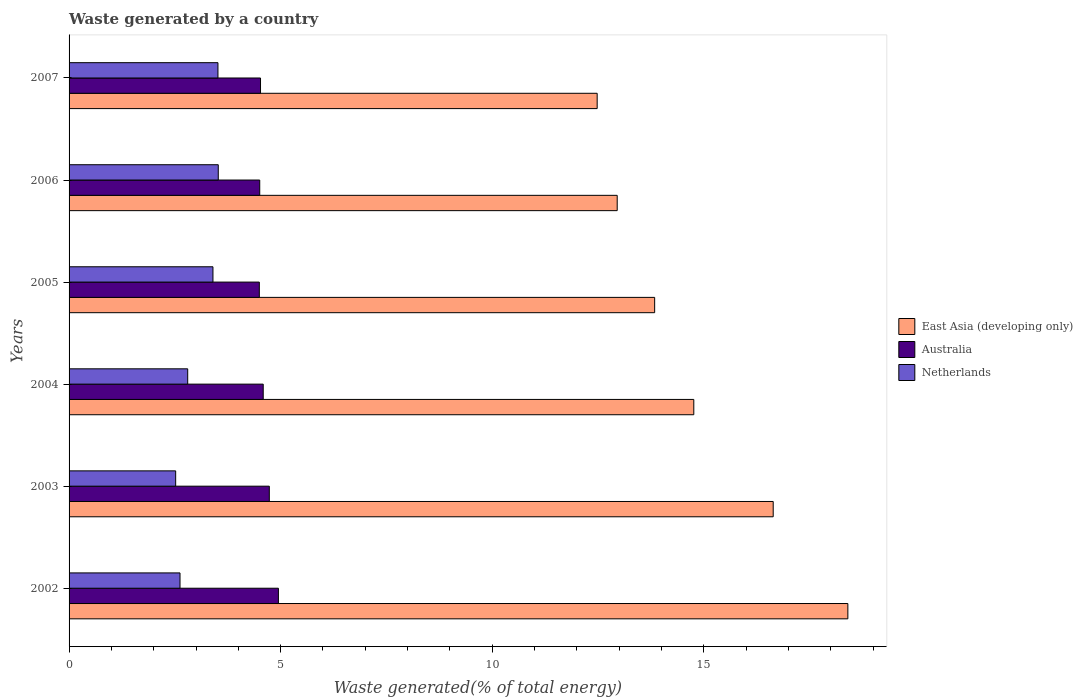How many groups of bars are there?
Your answer should be very brief. 6. Are the number of bars per tick equal to the number of legend labels?
Give a very brief answer. Yes. Are the number of bars on each tick of the Y-axis equal?
Your response must be concise. Yes. How many bars are there on the 5th tick from the top?
Your answer should be very brief. 3. What is the label of the 3rd group of bars from the top?
Provide a succinct answer. 2005. In how many cases, is the number of bars for a given year not equal to the number of legend labels?
Offer a very short reply. 0. What is the total waste generated in East Asia (developing only) in 2004?
Your answer should be compact. 14.76. Across all years, what is the maximum total waste generated in Netherlands?
Your answer should be compact. 3.53. Across all years, what is the minimum total waste generated in East Asia (developing only)?
Give a very brief answer. 12.48. In which year was the total waste generated in Australia minimum?
Ensure brevity in your answer.  2005. What is the total total waste generated in East Asia (developing only) in the graph?
Offer a terse response. 89.07. What is the difference between the total waste generated in Netherlands in 2005 and that in 2006?
Ensure brevity in your answer.  -0.13. What is the difference between the total waste generated in Australia in 2006 and the total waste generated in East Asia (developing only) in 2003?
Provide a short and direct response. -12.13. What is the average total waste generated in Australia per year?
Make the answer very short. 4.63. In the year 2006, what is the difference between the total waste generated in Netherlands and total waste generated in Australia?
Provide a short and direct response. -0.98. What is the ratio of the total waste generated in Netherlands in 2005 to that in 2006?
Your answer should be compact. 0.96. Is the total waste generated in East Asia (developing only) in 2003 less than that in 2007?
Keep it short and to the point. No. Is the difference between the total waste generated in Netherlands in 2004 and 2005 greater than the difference between the total waste generated in Australia in 2004 and 2005?
Provide a short and direct response. No. What is the difference between the highest and the second highest total waste generated in Australia?
Your response must be concise. 0.21. What is the difference between the highest and the lowest total waste generated in East Asia (developing only)?
Keep it short and to the point. 5.92. What does the 2nd bar from the top in 2007 represents?
Your answer should be very brief. Australia. What does the 3rd bar from the bottom in 2005 represents?
Make the answer very short. Netherlands. How many bars are there?
Provide a succinct answer. 18. Are all the bars in the graph horizontal?
Your answer should be very brief. Yes. How many years are there in the graph?
Ensure brevity in your answer.  6. Are the values on the major ticks of X-axis written in scientific E-notation?
Offer a terse response. No. Does the graph contain any zero values?
Give a very brief answer. No. How many legend labels are there?
Give a very brief answer. 3. What is the title of the graph?
Offer a terse response. Waste generated by a country. What is the label or title of the X-axis?
Keep it short and to the point. Waste generated(% of total energy). What is the Waste generated(% of total energy) of East Asia (developing only) in 2002?
Keep it short and to the point. 18.4. What is the Waste generated(% of total energy) in Australia in 2002?
Your answer should be compact. 4.95. What is the Waste generated(% of total energy) of Netherlands in 2002?
Your answer should be very brief. 2.62. What is the Waste generated(% of total energy) of East Asia (developing only) in 2003?
Offer a terse response. 16.64. What is the Waste generated(% of total energy) of Australia in 2003?
Offer a terse response. 4.73. What is the Waste generated(% of total energy) in Netherlands in 2003?
Your response must be concise. 2.52. What is the Waste generated(% of total energy) of East Asia (developing only) in 2004?
Offer a very short reply. 14.76. What is the Waste generated(% of total energy) in Australia in 2004?
Make the answer very short. 4.59. What is the Waste generated(% of total energy) in Netherlands in 2004?
Your response must be concise. 2.8. What is the Waste generated(% of total energy) in East Asia (developing only) in 2005?
Offer a terse response. 13.84. What is the Waste generated(% of total energy) in Australia in 2005?
Offer a very short reply. 4.5. What is the Waste generated(% of total energy) of Netherlands in 2005?
Your answer should be compact. 3.4. What is the Waste generated(% of total energy) in East Asia (developing only) in 2006?
Keep it short and to the point. 12.95. What is the Waste generated(% of total energy) in Australia in 2006?
Your answer should be very brief. 4.51. What is the Waste generated(% of total energy) in Netherlands in 2006?
Offer a terse response. 3.53. What is the Waste generated(% of total energy) in East Asia (developing only) in 2007?
Provide a succinct answer. 12.48. What is the Waste generated(% of total energy) in Australia in 2007?
Offer a very short reply. 4.52. What is the Waste generated(% of total energy) in Netherlands in 2007?
Make the answer very short. 3.52. Across all years, what is the maximum Waste generated(% of total energy) of East Asia (developing only)?
Provide a succinct answer. 18.4. Across all years, what is the maximum Waste generated(% of total energy) of Australia?
Keep it short and to the point. 4.95. Across all years, what is the maximum Waste generated(% of total energy) of Netherlands?
Your answer should be very brief. 3.53. Across all years, what is the minimum Waste generated(% of total energy) in East Asia (developing only)?
Keep it short and to the point. 12.48. Across all years, what is the minimum Waste generated(% of total energy) in Australia?
Keep it short and to the point. 4.5. Across all years, what is the minimum Waste generated(% of total energy) in Netherlands?
Provide a short and direct response. 2.52. What is the total Waste generated(% of total energy) of East Asia (developing only) in the graph?
Provide a succinct answer. 89.07. What is the total Waste generated(% of total energy) in Australia in the graph?
Offer a very short reply. 27.79. What is the total Waste generated(% of total energy) of Netherlands in the graph?
Your answer should be very brief. 18.39. What is the difference between the Waste generated(% of total energy) in East Asia (developing only) in 2002 and that in 2003?
Ensure brevity in your answer.  1.76. What is the difference between the Waste generated(% of total energy) of Australia in 2002 and that in 2003?
Offer a very short reply. 0.21. What is the difference between the Waste generated(% of total energy) in Netherlands in 2002 and that in 2003?
Provide a short and direct response. 0.1. What is the difference between the Waste generated(% of total energy) of East Asia (developing only) in 2002 and that in 2004?
Provide a short and direct response. 3.64. What is the difference between the Waste generated(% of total energy) of Australia in 2002 and that in 2004?
Your answer should be compact. 0.36. What is the difference between the Waste generated(% of total energy) of Netherlands in 2002 and that in 2004?
Your answer should be compact. -0.18. What is the difference between the Waste generated(% of total energy) in East Asia (developing only) in 2002 and that in 2005?
Make the answer very short. 4.57. What is the difference between the Waste generated(% of total energy) of Australia in 2002 and that in 2005?
Provide a short and direct response. 0.45. What is the difference between the Waste generated(% of total energy) in Netherlands in 2002 and that in 2005?
Provide a short and direct response. -0.78. What is the difference between the Waste generated(% of total energy) of East Asia (developing only) in 2002 and that in 2006?
Provide a short and direct response. 5.45. What is the difference between the Waste generated(% of total energy) of Australia in 2002 and that in 2006?
Your answer should be compact. 0.44. What is the difference between the Waste generated(% of total energy) of Netherlands in 2002 and that in 2006?
Offer a terse response. -0.9. What is the difference between the Waste generated(% of total energy) in East Asia (developing only) in 2002 and that in 2007?
Your answer should be very brief. 5.92. What is the difference between the Waste generated(% of total energy) in Australia in 2002 and that in 2007?
Keep it short and to the point. 0.42. What is the difference between the Waste generated(% of total energy) of Netherlands in 2002 and that in 2007?
Offer a terse response. -0.9. What is the difference between the Waste generated(% of total energy) of East Asia (developing only) in 2003 and that in 2004?
Provide a short and direct response. 1.88. What is the difference between the Waste generated(% of total energy) of Australia in 2003 and that in 2004?
Offer a terse response. 0.14. What is the difference between the Waste generated(% of total energy) of Netherlands in 2003 and that in 2004?
Give a very brief answer. -0.28. What is the difference between the Waste generated(% of total energy) in East Asia (developing only) in 2003 and that in 2005?
Provide a succinct answer. 2.8. What is the difference between the Waste generated(% of total energy) of Australia in 2003 and that in 2005?
Give a very brief answer. 0.24. What is the difference between the Waste generated(% of total energy) of Netherlands in 2003 and that in 2005?
Provide a short and direct response. -0.88. What is the difference between the Waste generated(% of total energy) of East Asia (developing only) in 2003 and that in 2006?
Provide a short and direct response. 3.69. What is the difference between the Waste generated(% of total energy) of Australia in 2003 and that in 2006?
Offer a very short reply. 0.23. What is the difference between the Waste generated(% of total energy) of Netherlands in 2003 and that in 2006?
Provide a short and direct response. -1.01. What is the difference between the Waste generated(% of total energy) in East Asia (developing only) in 2003 and that in 2007?
Give a very brief answer. 4.16. What is the difference between the Waste generated(% of total energy) in Australia in 2003 and that in 2007?
Offer a terse response. 0.21. What is the difference between the Waste generated(% of total energy) of Netherlands in 2003 and that in 2007?
Give a very brief answer. -1. What is the difference between the Waste generated(% of total energy) of East Asia (developing only) in 2004 and that in 2005?
Your response must be concise. 0.93. What is the difference between the Waste generated(% of total energy) in Australia in 2004 and that in 2005?
Your answer should be very brief. 0.09. What is the difference between the Waste generated(% of total energy) of Netherlands in 2004 and that in 2005?
Provide a short and direct response. -0.6. What is the difference between the Waste generated(% of total energy) in East Asia (developing only) in 2004 and that in 2006?
Offer a very short reply. 1.81. What is the difference between the Waste generated(% of total energy) of Australia in 2004 and that in 2006?
Ensure brevity in your answer.  0.08. What is the difference between the Waste generated(% of total energy) in Netherlands in 2004 and that in 2006?
Make the answer very short. -0.72. What is the difference between the Waste generated(% of total energy) of East Asia (developing only) in 2004 and that in 2007?
Provide a succinct answer. 2.28. What is the difference between the Waste generated(% of total energy) in Australia in 2004 and that in 2007?
Give a very brief answer. 0.06. What is the difference between the Waste generated(% of total energy) of Netherlands in 2004 and that in 2007?
Offer a terse response. -0.71. What is the difference between the Waste generated(% of total energy) of East Asia (developing only) in 2005 and that in 2006?
Provide a succinct answer. 0.88. What is the difference between the Waste generated(% of total energy) of Australia in 2005 and that in 2006?
Offer a terse response. -0.01. What is the difference between the Waste generated(% of total energy) in Netherlands in 2005 and that in 2006?
Make the answer very short. -0.13. What is the difference between the Waste generated(% of total energy) in East Asia (developing only) in 2005 and that in 2007?
Ensure brevity in your answer.  1.36. What is the difference between the Waste generated(% of total energy) in Australia in 2005 and that in 2007?
Give a very brief answer. -0.03. What is the difference between the Waste generated(% of total energy) in Netherlands in 2005 and that in 2007?
Your answer should be compact. -0.12. What is the difference between the Waste generated(% of total energy) of East Asia (developing only) in 2006 and that in 2007?
Give a very brief answer. 0.47. What is the difference between the Waste generated(% of total energy) in Australia in 2006 and that in 2007?
Keep it short and to the point. -0.02. What is the difference between the Waste generated(% of total energy) in Netherlands in 2006 and that in 2007?
Offer a very short reply. 0.01. What is the difference between the Waste generated(% of total energy) in East Asia (developing only) in 2002 and the Waste generated(% of total energy) in Australia in 2003?
Provide a succinct answer. 13.67. What is the difference between the Waste generated(% of total energy) of East Asia (developing only) in 2002 and the Waste generated(% of total energy) of Netherlands in 2003?
Your answer should be very brief. 15.88. What is the difference between the Waste generated(% of total energy) in Australia in 2002 and the Waste generated(% of total energy) in Netherlands in 2003?
Provide a short and direct response. 2.43. What is the difference between the Waste generated(% of total energy) of East Asia (developing only) in 2002 and the Waste generated(% of total energy) of Australia in 2004?
Your answer should be very brief. 13.81. What is the difference between the Waste generated(% of total energy) in East Asia (developing only) in 2002 and the Waste generated(% of total energy) in Netherlands in 2004?
Offer a terse response. 15.6. What is the difference between the Waste generated(% of total energy) in Australia in 2002 and the Waste generated(% of total energy) in Netherlands in 2004?
Make the answer very short. 2.14. What is the difference between the Waste generated(% of total energy) of East Asia (developing only) in 2002 and the Waste generated(% of total energy) of Australia in 2005?
Make the answer very short. 13.91. What is the difference between the Waste generated(% of total energy) of East Asia (developing only) in 2002 and the Waste generated(% of total energy) of Netherlands in 2005?
Provide a short and direct response. 15. What is the difference between the Waste generated(% of total energy) in Australia in 2002 and the Waste generated(% of total energy) in Netherlands in 2005?
Offer a terse response. 1.55. What is the difference between the Waste generated(% of total energy) in East Asia (developing only) in 2002 and the Waste generated(% of total energy) in Australia in 2006?
Provide a succinct answer. 13.9. What is the difference between the Waste generated(% of total energy) of East Asia (developing only) in 2002 and the Waste generated(% of total energy) of Netherlands in 2006?
Your answer should be compact. 14.88. What is the difference between the Waste generated(% of total energy) in Australia in 2002 and the Waste generated(% of total energy) in Netherlands in 2006?
Provide a succinct answer. 1.42. What is the difference between the Waste generated(% of total energy) of East Asia (developing only) in 2002 and the Waste generated(% of total energy) of Australia in 2007?
Provide a succinct answer. 13.88. What is the difference between the Waste generated(% of total energy) in East Asia (developing only) in 2002 and the Waste generated(% of total energy) in Netherlands in 2007?
Offer a terse response. 14.88. What is the difference between the Waste generated(% of total energy) in Australia in 2002 and the Waste generated(% of total energy) in Netherlands in 2007?
Your answer should be very brief. 1.43. What is the difference between the Waste generated(% of total energy) of East Asia (developing only) in 2003 and the Waste generated(% of total energy) of Australia in 2004?
Give a very brief answer. 12.05. What is the difference between the Waste generated(% of total energy) in East Asia (developing only) in 2003 and the Waste generated(% of total energy) in Netherlands in 2004?
Offer a terse response. 13.84. What is the difference between the Waste generated(% of total energy) in Australia in 2003 and the Waste generated(% of total energy) in Netherlands in 2004?
Your response must be concise. 1.93. What is the difference between the Waste generated(% of total energy) of East Asia (developing only) in 2003 and the Waste generated(% of total energy) of Australia in 2005?
Keep it short and to the point. 12.14. What is the difference between the Waste generated(% of total energy) of East Asia (developing only) in 2003 and the Waste generated(% of total energy) of Netherlands in 2005?
Your response must be concise. 13.24. What is the difference between the Waste generated(% of total energy) of Australia in 2003 and the Waste generated(% of total energy) of Netherlands in 2005?
Give a very brief answer. 1.33. What is the difference between the Waste generated(% of total energy) of East Asia (developing only) in 2003 and the Waste generated(% of total energy) of Australia in 2006?
Make the answer very short. 12.13. What is the difference between the Waste generated(% of total energy) in East Asia (developing only) in 2003 and the Waste generated(% of total energy) in Netherlands in 2006?
Provide a succinct answer. 13.11. What is the difference between the Waste generated(% of total energy) in Australia in 2003 and the Waste generated(% of total energy) in Netherlands in 2006?
Offer a very short reply. 1.21. What is the difference between the Waste generated(% of total energy) of East Asia (developing only) in 2003 and the Waste generated(% of total energy) of Australia in 2007?
Provide a short and direct response. 12.11. What is the difference between the Waste generated(% of total energy) in East Asia (developing only) in 2003 and the Waste generated(% of total energy) in Netherlands in 2007?
Provide a short and direct response. 13.12. What is the difference between the Waste generated(% of total energy) in Australia in 2003 and the Waste generated(% of total energy) in Netherlands in 2007?
Your answer should be compact. 1.21. What is the difference between the Waste generated(% of total energy) of East Asia (developing only) in 2004 and the Waste generated(% of total energy) of Australia in 2005?
Your answer should be very brief. 10.27. What is the difference between the Waste generated(% of total energy) in East Asia (developing only) in 2004 and the Waste generated(% of total energy) in Netherlands in 2005?
Keep it short and to the point. 11.36. What is the difference between the Waste generated(% of total energy) in Australia in 2004 and the Waste generated(% of total energy) in Netherlands in 2005?
Provide a succinct answer. 1.19. What is the difference between the Waste generated(% of total energy) in East Asia (developing only) in 2004 and the Waste generated(% of total energy) in Australia in 2006?
Make the answer very short. 10.26. What is the difference between the Waste generated(% of total energy) in East Asia (developing only) in 2004 and the Waste generated(% of total energy) in Netherlands in 2006?
Offer a terse response. 11.24. What is the difference between the Waste generated(% of total energy) in Australia in 2004 and the Waste generated(% of total energy) in Netherlands in 2006?
Keep it short and to the point. 1.06. What is the difference between the Waste generated(% of total energy) in East Asia (developing only) in 2004 and the Waste generated(% of total energy) in Australia in 2007?
Your response must be concise. 10.24. What is the difference between the Waste generated(% of total energy) in East Asia (developing only) in 2004 and the Waste generated(% of total energy) in Netherlands in 2007?
Provide a short and direct response. 11.24. What is the difference between the Waste generated(% of total energy) in Australia in 2004 and the Waste generated(% of total energy) in Netherlands in 2007?
Offer a terse response. 1.07. What is the difference between the Waste generated(% of total energy) in East Asia (developing only) in 2005 and the Waste generated(% of total energy) in Australia in 2006?
Keep it short and to the point. 9.33. What is the difference between the Waste generated(% of total energy) in East Asia (developing only) in 2005 and the Waste generated(% of total energy) in Netherlands in 2006?
Offer a very short reply. 10.31. What is the difference between the Waste generated(% of total energy) of Australia in 2005 and the Waste generated(% of total energy) of Netherlands in 2006?
Offer a terse response. 0.97. What is the difference between the Waste generated(% of total energy) in East Asia (developing only) in 2005 and the Waste generated(% of total energy) in Australia in 2007?
Ensure brevity in your answer.  9.31. What is the difference between the Waste generated(% of total energy) of East Asia (developing only) in 2005 and the Waste generated(% of total energy) of Netherlands in 2007?
Your answer should be compact. 10.32. What is the difference between the Waste generated(% of total energy) in Australia in 2005 and the Waste generated(% of total energy) in Netherlands in 2007?
Give a very brief answer. 0.98. What is the difference between the Waste generated(% of total energy) of East Asia (developing only) in 2006 and the Waste generated(% of total energy) of Australia in 2007?
Your answer should be compact. 8.43. What is the difference between the Waste generated(% of total energy) of East Asia (developing only) in 2006 and the Waste generated(% of total energy) of Netherlands in 2007?
Make the answer very short. 9.43. What is the difference between the Waste generated(% of total energy) of Australia in 2006 and the Waste generated(% of total energy) of Netherlands in 2007?
Your answer should be compact. 0.99. What is the average Waste generated(% of total energy) in East Asia (developing only) per year?
Your answer should be very brief. 14.85. What is the average Waste generated(% of total energy) in Australia per year?
Provide a short and direct response. 4.63. What is the average Waste generated(% of total energy) in Netherlands per year?
Your answer should be very brief. 3.06. In the year 2002, what is the difference between the Waste generated(% of total energy) in East Asia (developing only) and Waste generated(% of total energy) in Australia?
Provide a succinct answer. 13.46. In the year 2002, what is the difference between the Waste generated(% of total energy) in East Asia (developing only) and Waste generated(% of total energy) in Netherlands?
Make the answer very short. 15.78. In the year 2002, what is the difference between the Waste generated(% of total energy) in Australia and Waste generated(% of total energy) in Netherlands?
Offer a very short reply. 2.32. In the year 2003, what is the difference between the Waste generated(% of total energy) of East Asia (developing only) and Waste generated(% of total energy) of Australia?
Provide a succinct answer. 11.91. In the year 2003, what is the difference between the Waste generated(% of total energy) in East Asia (developing only) and Waste generated(% of total energy) in Netherlands?
Keep it short and to the point. 14.12. In the year 2003, what is the difference between the Waste generated(% of total energy) of Australia and Waste generated(% of total energy) of Netherlands?
Keep it short and to the point. 2.21. In the year 2004, what is the difference between the Waste generated(% of total energy) in East Asia (developing only) and Waste generated(% of total energy) in Australia?
Your response must be concise. 10.17. In the year 2004, what is the difference between the Waste generated(% of total energy) in East Asia (developing only) and Waste generated(% of total energy) in Netherlands?
Provide a succinct answer. 11.96. In the year 2004, what is the difference between the Waste generated(% of total energy) in Australia and Waste generated(% of total energy) in Netherlands?
Your response must be concise. 1.78. In the year 2005, what is the difference between the Waste generated(% of total energy) in East Asia (developing only) and Waste generated(% of total energy) in Australia?
Offer a very short reply. 9.34. In the year 2005, what is the difference between the Waste generated(% of total energy) in East Asia (developing only) and Waste generated(% of total energy) in Netherlands?
Give a very brief answer. 10.44. In the year 2005, what is the difference between the Waste generated(% of total energy) of Australia and Waste generated(% of total energy) of Netherlands?
Provide a short and direct response. 1.1. In the year 2006, what is the difference between the Waste generated(% of total energy) of East Asia (developing only) and Waste generated(% of total energy) of Australia?
Make the answer very short. 8.45. In the year 2006, what is the difference between the Waste generated(% of total energy) in East Asia (developing only) and Waste generated(% of total energy) in Netherlands?
Offer a very short reply. 9.43. In the year 2006, what is the difference between the Waste generated(% of total energy) of Australia and Waste generated(% of total energy) of Netherlands?
Provide a succinct answer. 0.98. In the year 2007, what is the difference between the Waste generated(% of total energy) of East Asia (developing only) and Waste generated(% of total energy) of Australia?
Your answer should be very brief. 7.96. In the year 2007, what is the difference between the Waste generated(% of total energy) of East Asia (developing only) and Waste generated(% of total energy) of Netherlands?
Keep it short and to the point. 8.96. What is the ratio of the Waste generated(% of total energy) of East Asia (developing only) in 2002 to that in 2003?
Ensure brevity in your answer.  1.11. What is the ratio of the Waste generated(% of total energy) in Australia in 2002 to that in 2003?
Keep it short and to the point. 1.05. What is the ratio of the Waste generated(% of total energy) in Netherlands in 2002 to that in 2003?
Ensure brevity in your answer.  1.04. What is the ratio of the Waste generated(% of total energy) of East Asia (developing only) in 2002 to that in 2004?
Ensure brevity in your answer.  1.25. What is the ratio of the Waste generated(% of total energy) in Australia in 2002 to that in 2004?
Ensure brevity in your answer.  1.08. What is the ratio of the Waste generated(% of total energy) of Netherlands in 2002 to that in 2004?
Offer a very short reply. 0.94. What is the ratio of the Waste generated(% of total energy) of East Asia (developing only) in 2002 to that in 2005?
Your response must be concise. 1.33. What is the ratio of the Waste generated(% of total energy) in Australia in 2002 to that in 2005?
Ensure brevity in your answer.  1.1. What is the ratio of the Waste generated(% of total energy) in Netherlands in 2002 to that in 2005?
Keep it short and to the point. 0.77. What is the ratio of the Waste generated(% of total energy) in East Asia (developing only) in 2002 to that in 2006?
Provide a short and direct response. 1.42. What is the ratio of the Waste generated(% of total energy) of Australia in 2002 to that in 2006?
Make the answer very short. 1.1. What is the ratio of the Waste generated(% of total energy) of Netherlands in 2002 to that in 2006?
Make the answer very short. 0.74. What is the ratio of the Waste generated(% of total energy) in East Asia (developing only) in 2002 to that in 2007?
Provide a succinct answer. 1.47. What is the ratio of the Waste generated(% of total energy) in Australia in 2002 to that in 2007?
Provide a succinct answer. 1.09. What is the ratio of the Waste generated(% of total energy) in Netherlands in 2002 to that in 2007?
Ensure brevity in your answer.  0.75. What is the ratio of the Waste generated(% of total energy) in East Asia (developing only) in 2003 to that in 2004?
Make the answer very short. 1.13. What is the ratio of the Waste generated(% of total energy) of Australia in 2003 to that in 2004?
Offer a very short reply. 1.03. What is the ratio of the Waste generated(% of total energy) in Netherlands in 2003 to that in 2004?
Offer a very short reply. 0.9. What is the ratio of the Waste generated(% of total energy) of East Asia (developing only) in 2003 to that in 2005?
Offer a terse response. 1.2. What is the ratio of the Waste generated(% of total energy) of Australia in 2003 to that in 2005?
Make the answer very short. 1.05. What is the ratio of the Waste generated(% of total energy) of Netherlands in 2003 to that in 2005?
Make the answer very short. 0.74. What is the ratio of the Waste generated(% of total energy) of East Asia (developing only) in 2003 to that in 2006?
Your answer should be compact. 1.28. What is the ratio of the Waste generated(% of total energy) of Australia in 2003 to that in 2006?
Keep it short and to the point. 1.05. What is the ratio of the Waste generated(% of total energy) of Netherlands in 2003 to that in 2006?
Your response must be concise. 0.71. What is the ratio of the Waste generated(% of total energy) in East Asia (developing only) in 2003 to that in 2007?
Give a very brief answer. 1.33. What is the ratio of the Waste generated(% of total energy) of Australia in 2003 to that in 2007?
Give a very brief answer. 1.05. What is the ratio of the Waste generated(% of total energy) of Netherlands in 2003 to that in 2007?
Your answer should be compact. 0.72. What is the ratio of the Waste generated(% of total energy) in East Asia (developing only) in 2004 to that in 2005?
Offer a very short reply. 1.07. What is the ratio of the Waste generated(% of total energy) of Australia in 2004 to that in 2005?
Provide a succinct answer. 1.02. What is the ratio of the Waste generated(% of total energy) in Netherlands in 2004 to that in 2005?
Make the answer very short. 0.82. What is the ratio of the Waste generated(% of total energy) in East Asia (developing only) in 2004 to that in 2006?
Your answer should be compact. 1.14. What is the ratio of the Waste generated(% of total energy) in Australia in 2004 to that in 2006?
Your answer should be compact. 1.02. What is the ratio of the Waste generated(% of total energy) of Netherlands in 2004 to that in 2006?
Give a very brief answer. 0.8. What is the ratio of the Waste generated(% of total energy) of East Asia (developing only) in 2004 to that in 2007?
Your response must be concise. 1.18. What is the ratio of the Waste generated(% of total energy) of Australia in 2004 to that in 2007?
Provide a succinct answer. 1.01. What is the ratio of the Waste generated(% of total energy) of Netherlands in 2004 to that in 2007?
Ensure brevity in your answer.  0.8. What is the ratio of the Waste generated(% of total energy) in East Asia (developing only) in 2005 to that in 2006?
Provide a short and direct response. 1.07. What is the ratio of the Waste generated(% of total energy) in Australia in 2005 to that in 2006?
Keep it short and to the point. 1. What is the ratio of the Waste generated(% of total energy) in Netherlands in 2005 to that in 2006?
Provide a succinct answer. 0.96. What is the ratio of the Waste generated(% of total energy) in East Asia (developing only) in 2005 to that in 2007?
Your response must be concise. 1.11. What is the ratio of the Waste generated(% of total energy) of Australia in 2005 to that in 2007?
Keep it short and to the point. 0.99. What is the ratio of the Waste generated(% of total energy) of Netherlands in 2005 to that in 2007?
Your answer should be compact. 0.97. What is the ratio of the Waste generated(% of total energy) of East Asia (developing only) in 2006 to that in 2007?
Provide a succinct answer. 1.04. What is the ratio of the Waste generated(% of total energy) in Australia in 2006 to that in 2007?
Give a very brief answer. 1. What is the ratio of the Waste generated(% of total energy) of Netherlands in 2006 to that in 2007?
Your answer should be compact. 1. What is the difference between the highest and the second highest Waste generated(% of total energy) in East Asia (developing only)?
Ensure brevity in your answer.  1.76. What is the difference between the highest and the second highest Waste generated(% of total energy) of Australia?
Keep it short and to the point. 0.21. What is the difference between the highest and the second highest Waste generated(% of total energy) in Netherlands?
Give a very brief answer. 0.01. What is the difference between the highest and the lowest Waste generated(% of total energy) of East Asia (developing only)?
Make the answer very short. 5.92. What is the difference between the highest and the lowest Waste generated(% of total energy) in Australia?
Offer a terse response. 0.45. What is the difference between the highest and the lowest Waste generated(% of total energy) of Netherlands?
Your response must be concise. 1.01. 